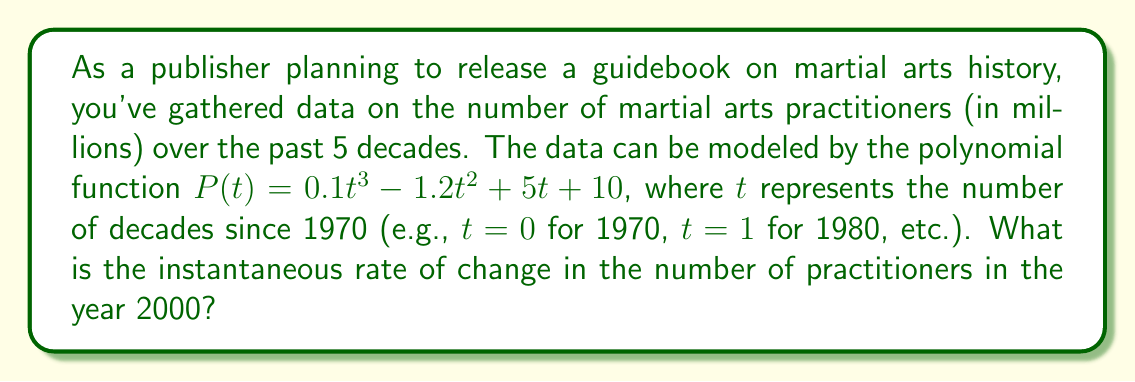What is the answer to this math problem? To find the instantaneous rate of change in the year 2000, we need to follow these steps:

1. Identify the value of $t$ for the year 2000:
   2000 is 3 decades after 1970, so $t = 3$

2. Find the derivative of the polynomial function $P(t)$:
   $P(t) = 0.1t^3 - 1.2t^2 + 5t + 10$
   $P'(t) = 0.3t^2 - 2.4t + 5$

3. Evaluate the derivative at $t = 3$:
   $P'(3) = 0.3(3)^2 - 2.4(3) + 5$
   $= 0.3(9) - 7.2 + 5$
   $= 2.7 - 7.2 + 5$
   $= 0.5$

The instantaneous rate of change is 0.5 million practitioners per decade, which is equivalent to 50,000 practitioners per year.
Answer: 50,000 practitioners per year 